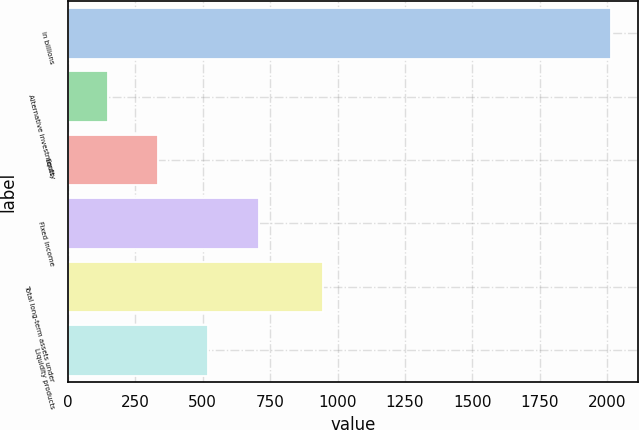<chart> <loc_0><loc_0><loc_500><loc_500><bar_chart><fcel>in billions<fcel>Alternative investments<fcel>Equity<fcel>Fixed income<fcel>Total long-term assets under<fcel>Liquidity products<nl><fcel>2015<fcel>148<fcel>334.7<fcel>708.1<fcel>946<fcel>521.4<nl></chart> 